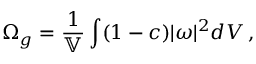<formula> <loc_0><loc_0><loc_500><loc_500>\Omega _ { g } = \frac { 1 } { \mathbb { V } } \int ( 1 - c ) | \omega | ^ { 2 } d V \, ,</formula> 